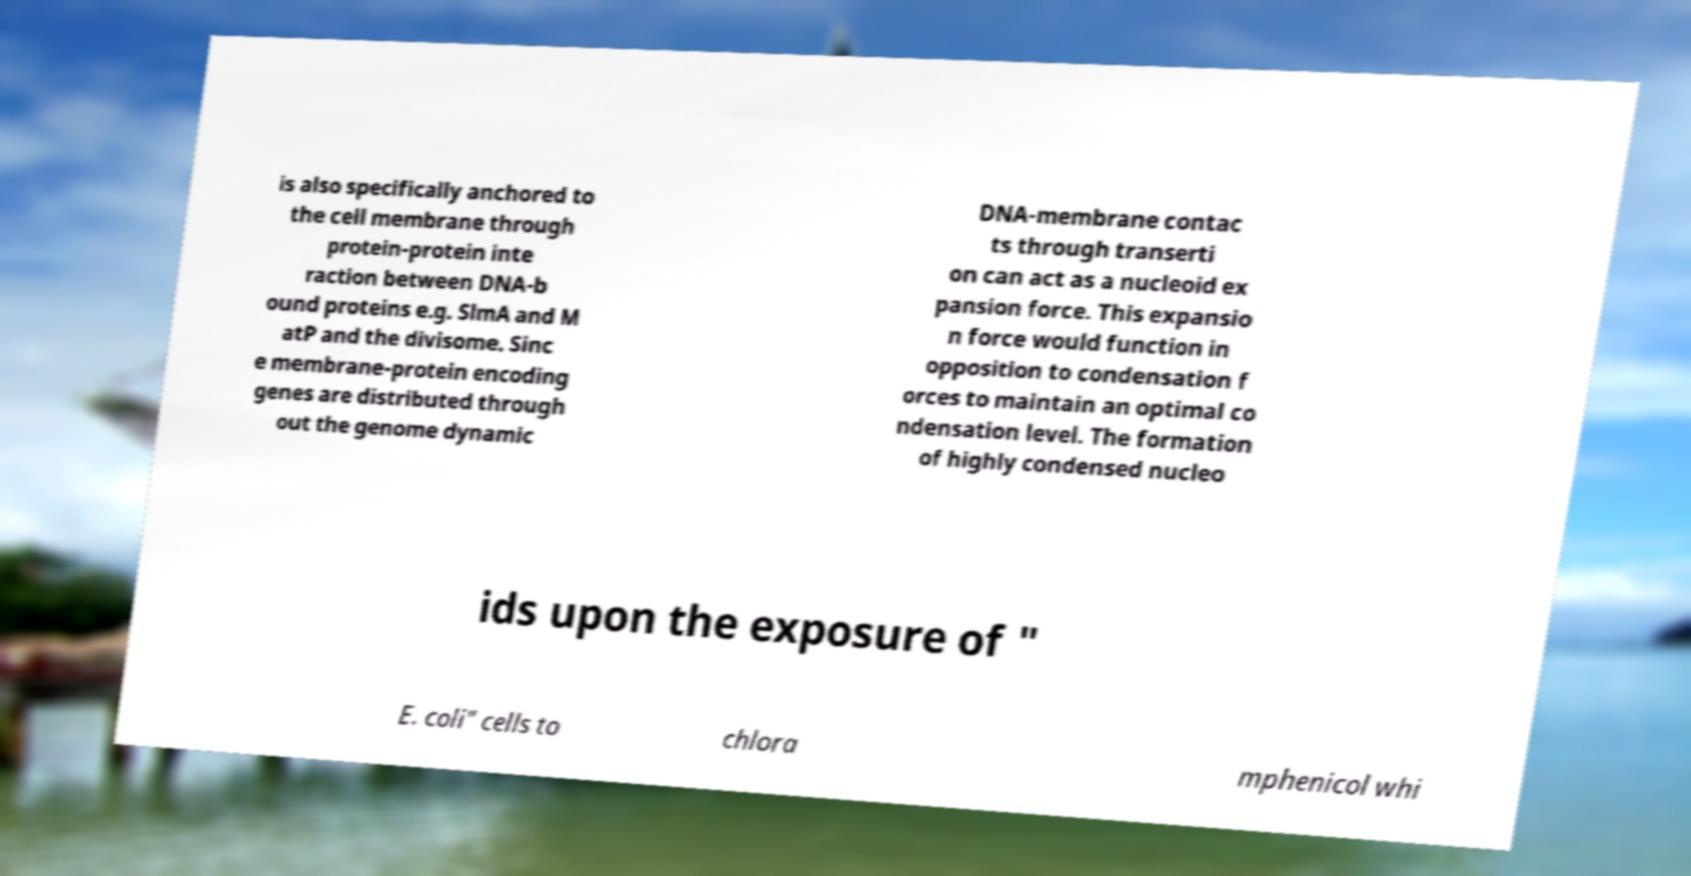Could you extract and type out the text from this image? is also specifically anchored to the cell membrane through protein-protein inte raction between DNA-b ound proteins e.g. SlmA and M atP and the divisome. Sinc e membrane-protein encoding genes are distributed through out the genome dynamic DNA-membrane contac ts through transerti on can act as a nucleoid ex pansion force. This expansio n force would function in opposition to condensation f orces to maintain an optimal co ndensation level. The formation of highly condensed nucleo ids upon the exposure of " E. coli" cells to chlora mphenicol whi 